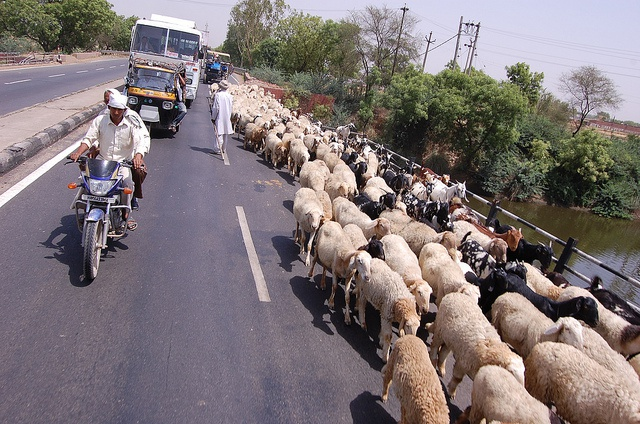Describe the objects in this image and their specific colors. I can see sheep in darkgreen, tan, maroon, gray, and brown tones, sheep in darkgreen, lightgray, brown, tan, and maroon tones, motorcycle in darkgreen, black, gray, darkgray, and navy tones, sheep in darkgreen, tan, gray, and maroon tones, and people in darkgreen, white, darkgray, and gray tones in this image. 